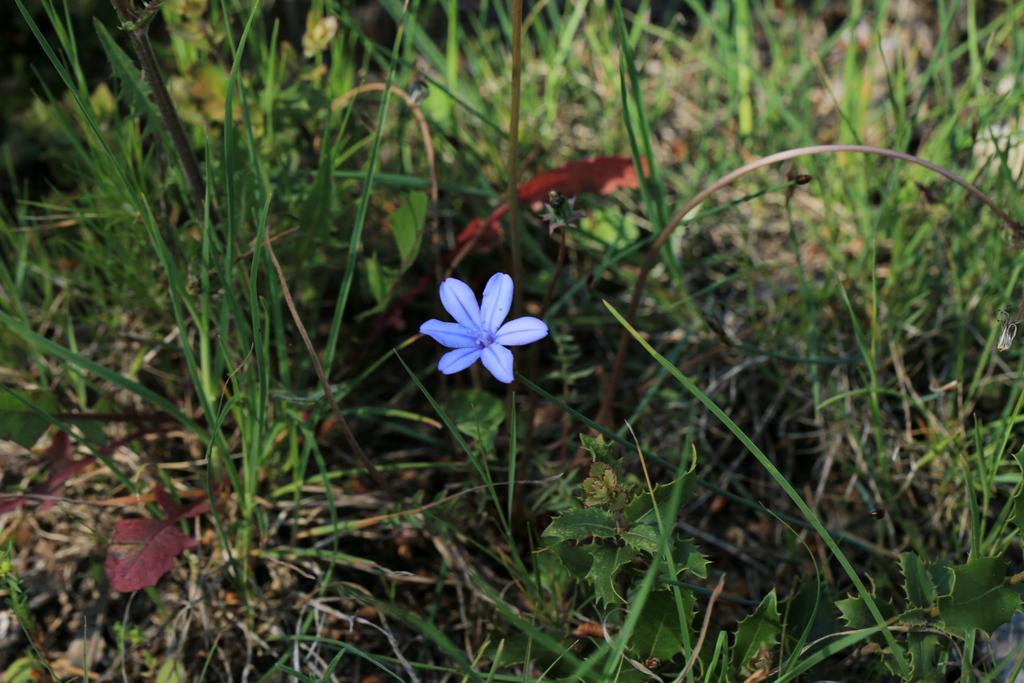What type of vegetation is present in the image? There is grass and plants in the image. Can you identify any specific type of plant in the image? Yes, there is a flower in the image. Reasoning: Let's think step by identifying the main subjects and objects in the image based on the provided facts. We then formulate questions that focus on the location and characteristics of these subjects and objects, ensuring that each question can be answered definitively with the information given. We avoid yes/no questions and ensure that the language is simple and clear. Absurd Question/Answer: How many worms can be seen crawling on the flower in the image? There are no worms present in the image. What type of machine is visible in the background of the image? There is no machine visible in the image; it features grass, plants, and a flower. 